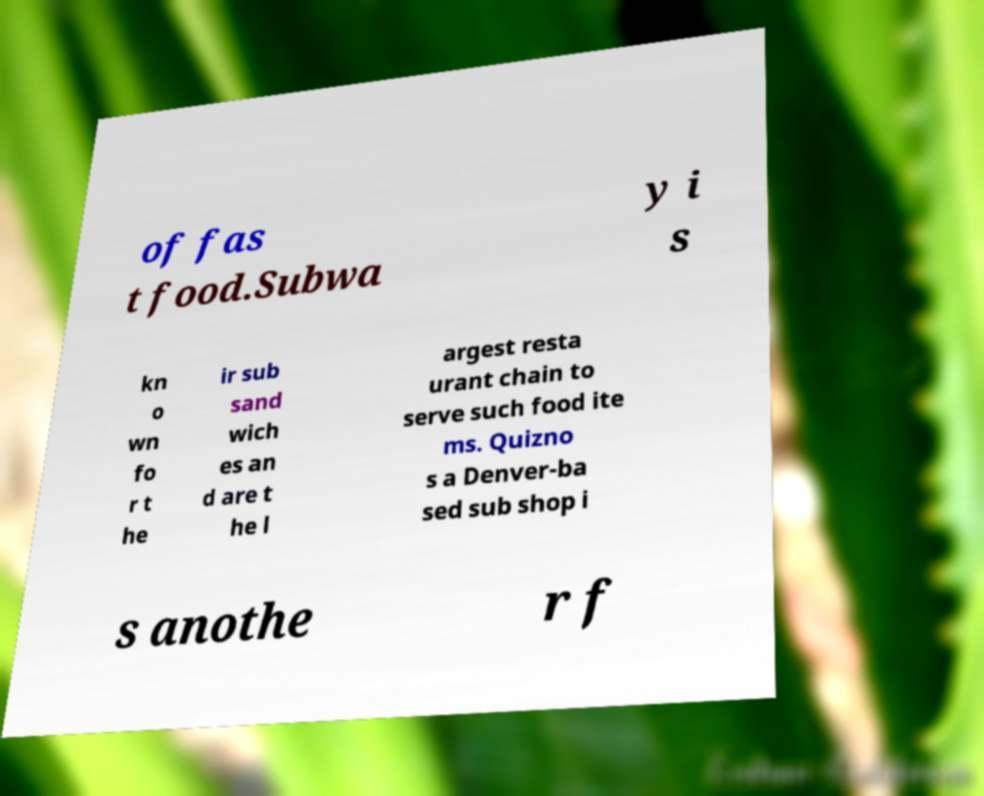Please identify and transcribe the text found in this image. of fas t food.Subwa y i s kn o wn fo r t he ir sub sand wich es an d are t he l argest resta urant chain to serve such food ite ms. Quizno s a Denver-ba sed sub shop i s anothe r f 